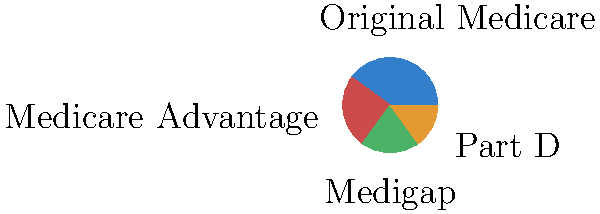Based on the pie chart showing Medicare coverage options in Marion County, AL, what percentage of seniors are enrolled in Medicare Advantage plans? To answer this question, we need to interpret the pie chart correctly:

1. The pie chart shows four different Medicare coverage options.
2. Each segment of the pie represents a different option, with its size proportional to the percentage of seniors enrolled.
3. The segments are labeled with the name of each option.
4. To find the percentage for Medicare Advantage, we need to locate its corresponding segment.
5. The red segment is labeled "Medicare Advantage".
6. By examining the size of this segment, we can see it represents 25% of the total pie.

Therefore, the percentage of seniors enrolled in Medicare Advantage plans is 25%.
Answer: 25% 